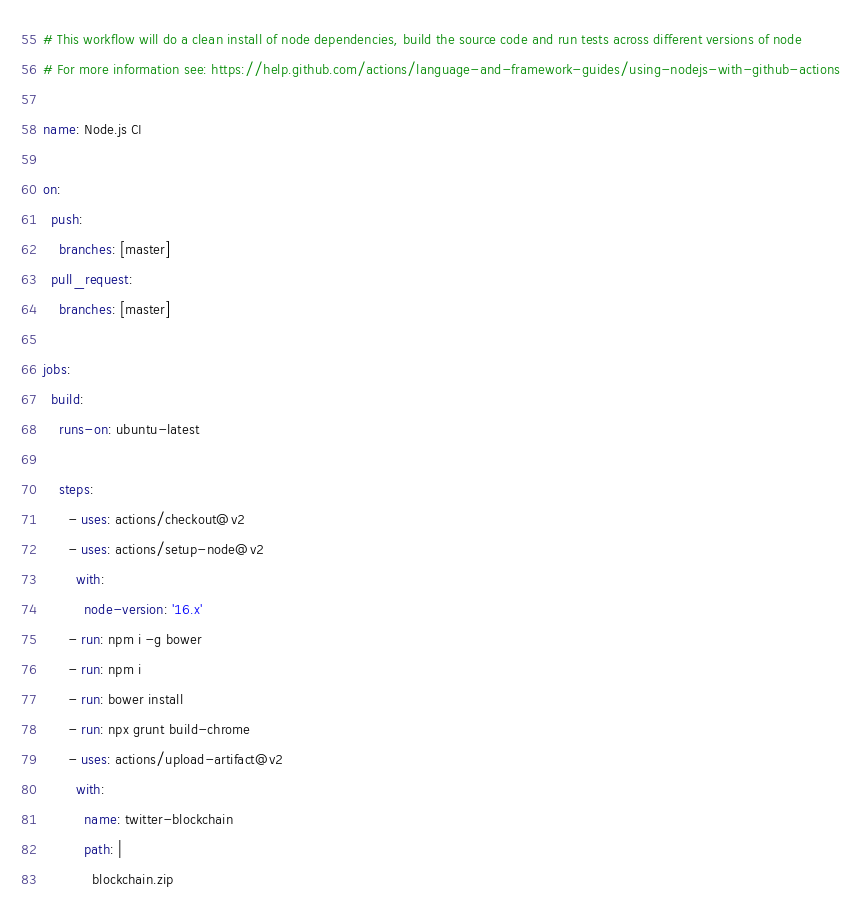<code> <loc_0><loc_0><loc_500><loc_500><_YAML_># This workflow will do a clean install of node dependencies, build the source code and run tests across different versions of node
# For more information see: https://help.github.com/actions/language-and-framework-guides/using-nodejs-with-github-actions

name: Node.js CI

on:
  push:
    branches: [master]
  pull_request:
    branches: [master]

jobs:
  build:
    runs-on: ubuntu-latest

    steps:
      - uses: actions/checkout@v2
      - uses: actions/setup-node@v2
        with:
          node-version: '16.x'
      - run: npm i -g bower
      - run: npm i
      - run: bower install
      - run: npx grunt build-chrome
      - uses: actions/upload-artifact@v2
        with:
          name: twitter-blockchain
          path: |
            blockchain.zip
</code> 